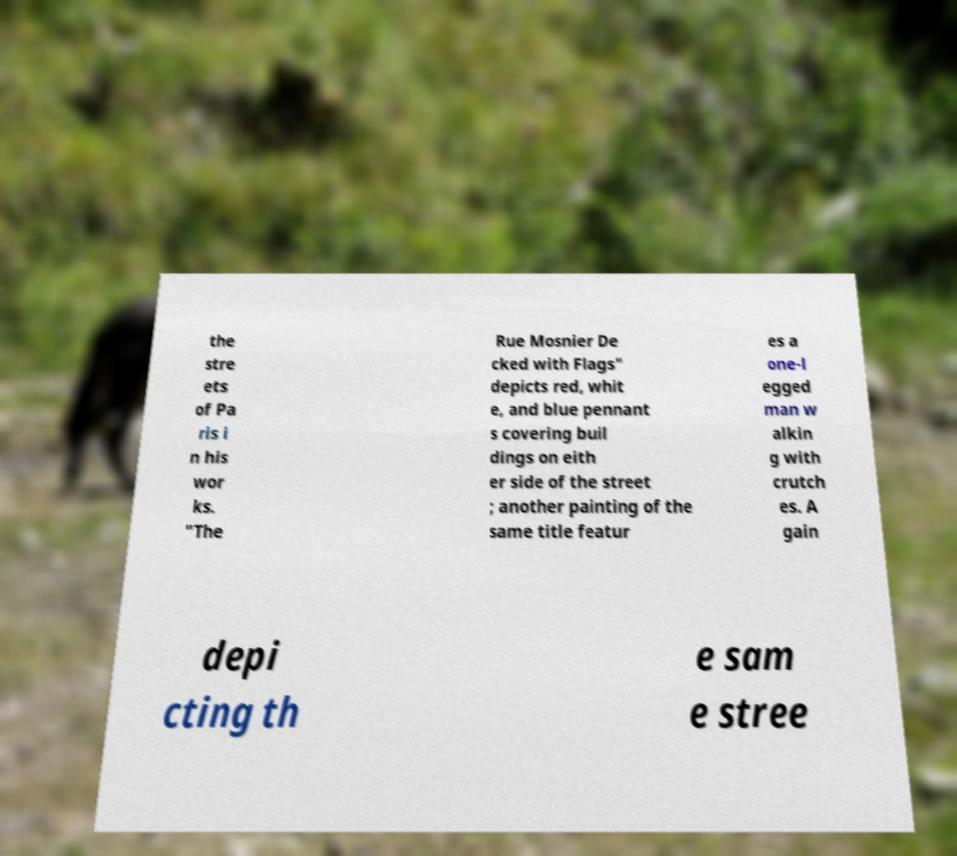I need the written content from this picture converted into text. Can you do that? the stre ets of Pa ris i n his wor ks. "The Rue Mosnier De cked with Flags" depicts red, whit e, and blue pennant s covering buil dings on eith er side of the street ; another painting of the same title featur es a one-l egged man w alkin g with crutch es. A gain depi cting th e sam e stree 